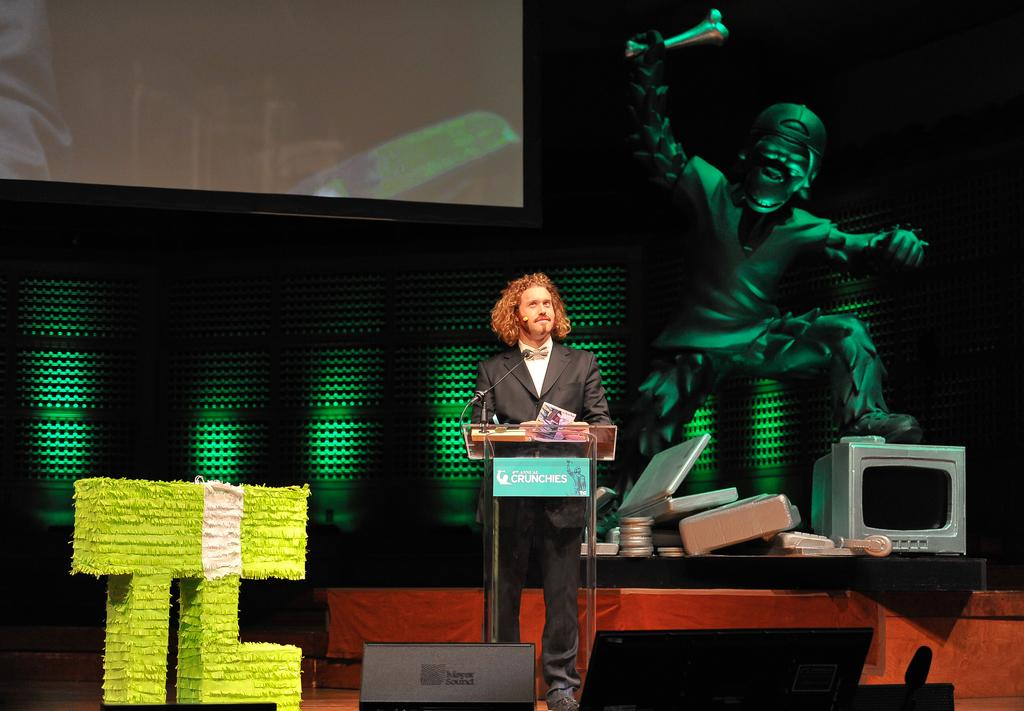<image>
Provide a brief description of the given image. Man doing a presentation on stage with the wording Crunchies on the podium. 